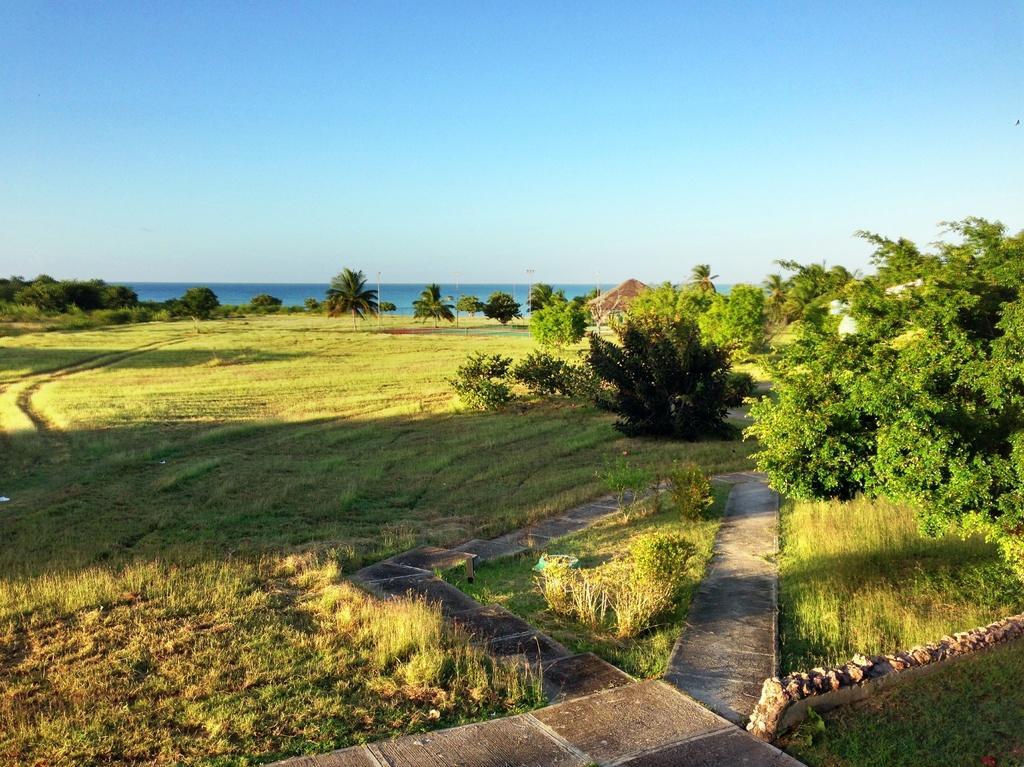Please provide a concise description of this image. In this image we can see some trees, grass, houses and plants, in the background we can see the sky. 